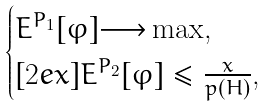<formula> <loc_0><loc_0><loc_500><loc_500>\begin{cases} E ^ { P _ { 1 } } [ \varphi ] { \longrightarrow } \max , \\ [ 2 e x ] E ^ { P _ { 2 } } [ \varphi ] \leq \frac { x } { p ( H ) } , \end{cases}</formula> 